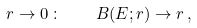Convert formula to latex. <formula><loc_0><loc_0><loc_500><loc_500>r \to 0 \, \colon \quad B ( E ; r ) \to r \, ,</formula> 